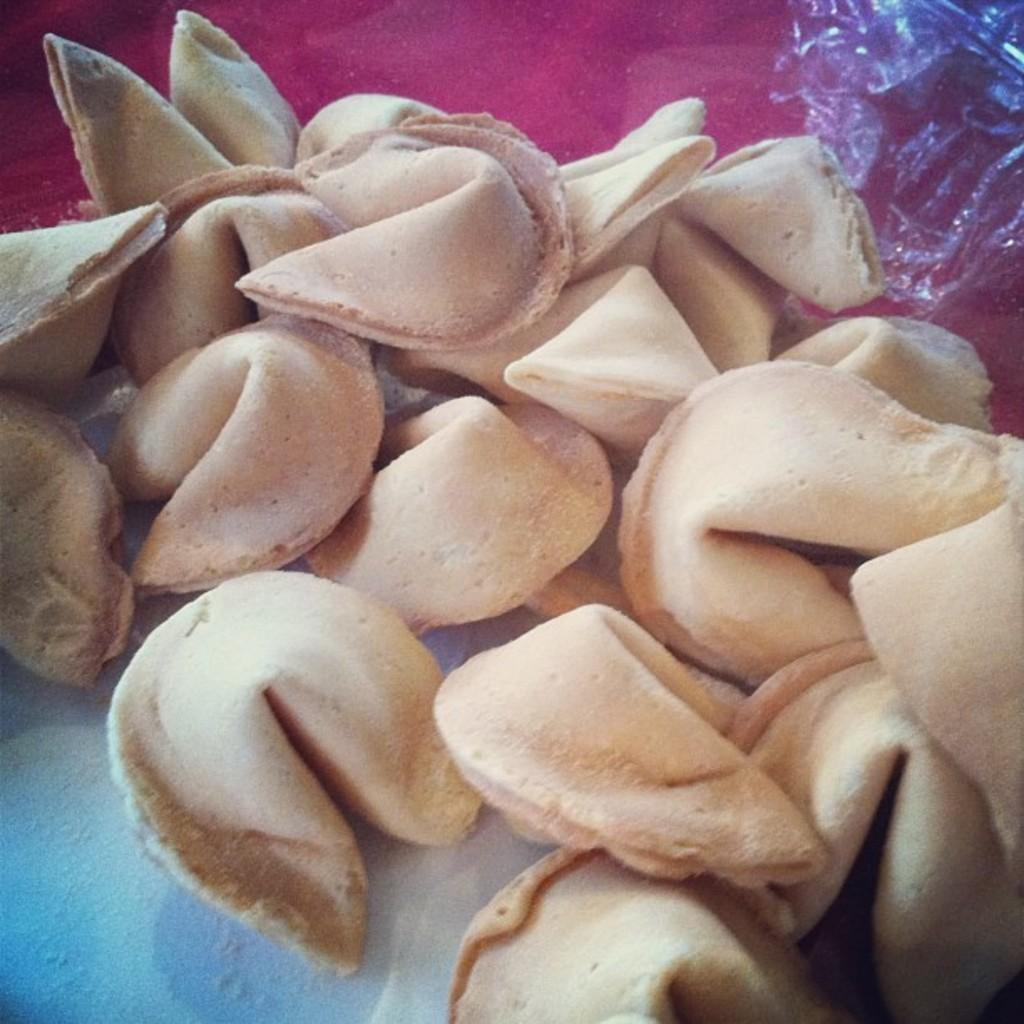What type of food can be seen in the image? There are raw dumplings in the image. Can you describe the appearance of the dumplings? The dumplings appear to be uncooked and may have a doughy texture. What might be the next step in preparing the dumplings? The next step in preparing the dumplings might be to cook them, either by boiling, steaming, or frying. What type of star can be seen shining above the dumplings in the image? There is no star visible in the image, as it is focused on raw dumplings and does not include any celestial objects. 